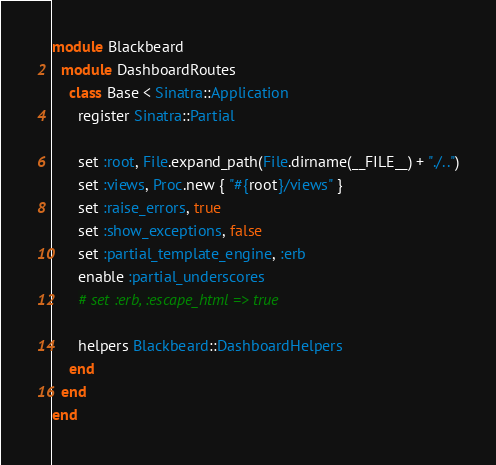<code> <loc_0><loc_0><loc_500><loc_500><_Ruby_>module Blackbeard
  module DashboardRoutes
    class Base < Sinatra::Application
      register Sinatra::Partial

      set :root, File.expand_path(File.dirname(__FILE__) + "./..")
      set :views, Proc.new { "#{root}/views" }
      set :raise_errors, true
      set :show_exceptions, false
      set :partial_template_engine, :erb
      enable :partial_underscores
      # set :erb, :escape_html => true

      helpers Blackbeard::DashboardHelpers
    end
  end
end
</code> 